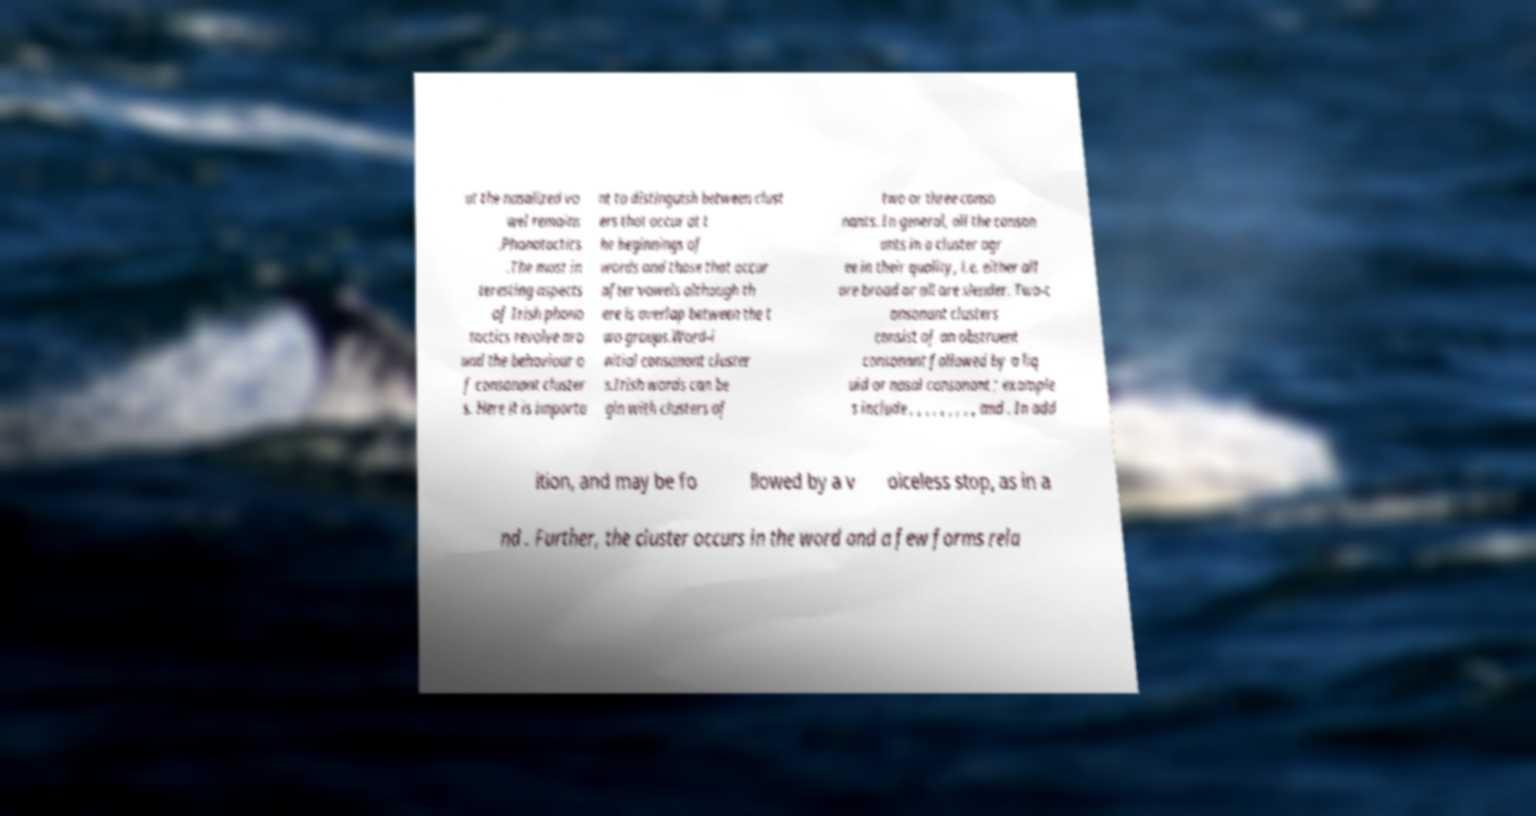Can you read and provide the text displayed in the image?This photo seems to have some interesting text. Can you extract and type it out for me? ut the nasalized vo wel remains .Phonotactics .The most in teresting aspects of Irish phono tactics revolve aro und the behaviour o f consonant cluster s. Here it is importa nt to distinguish between clust ers that occur at t he beginnings of words and those that occur after vowels although th ere is overlap between the t wo groups.Word-i nitial consonant cluster s.Irish words can be gin with clusters of two or three conso nants. In general, all the conson ants in a cluster agr ee in their quality, i.e. either all are broad or all are slender. Two-c onsonant clusters consist of an obstruent consonant followed by a liq uid or nasal consonant ; example s include , , , , , , , , , and . In add ition, and may be fo llowed by a v oiceless stop, as in a nd . Further, the cluster occurs in the word and a few forms rela 